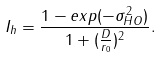<formula> <loc_0><loc_0><loc_500><loc_500>I _ { h } = \frac { 1 - e x p ( - \sigma _ { H O } ^ { 2 } ) } { 1 + ( \frac { D } { r _ { 0 } } ) ^ { 2 } } .</formula> 